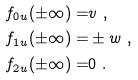Convert formula to latex. <formula><loc_0><loc_0><loc_500><loc_500>f _ { 0 u } ( \pm \infty ) = & v \ , \\ f _ { 1 u } ( \pm \infty ) = & \pm w \ , \\ f _ { 2 u } ( \pm \infty ) = & 0 \ .</formula> 